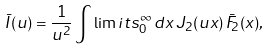<formula> <loc_0><loc_0><loc_500><loc_500>\bar { I } ( u ) = \frac { 1 } { u ^ { 2 } } \int \lim i t s _ { 0 } ^ { \infty } \, d x \, J _ { 2 } ( u x ) \, \bar { F } _ { 2 } ( x ) ,</formula> 